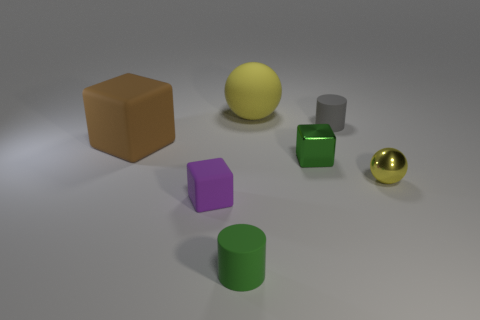Subtract all small blocks. How many blocks are left? 1 Add 3 tiny gray matte objects. How many objects exist? 10 Subtract all cylinders. How many objects are left? 5 Add 7 purple blocks. How many purple blocks are left? 8 Add 1 brown objects. How many brown objects exist? 2 Subtract 0 cyan blocks. How many objects are left? 7 Subtract all yellow things. Subtract all big brown rubber objects. How many objects are left? 4 